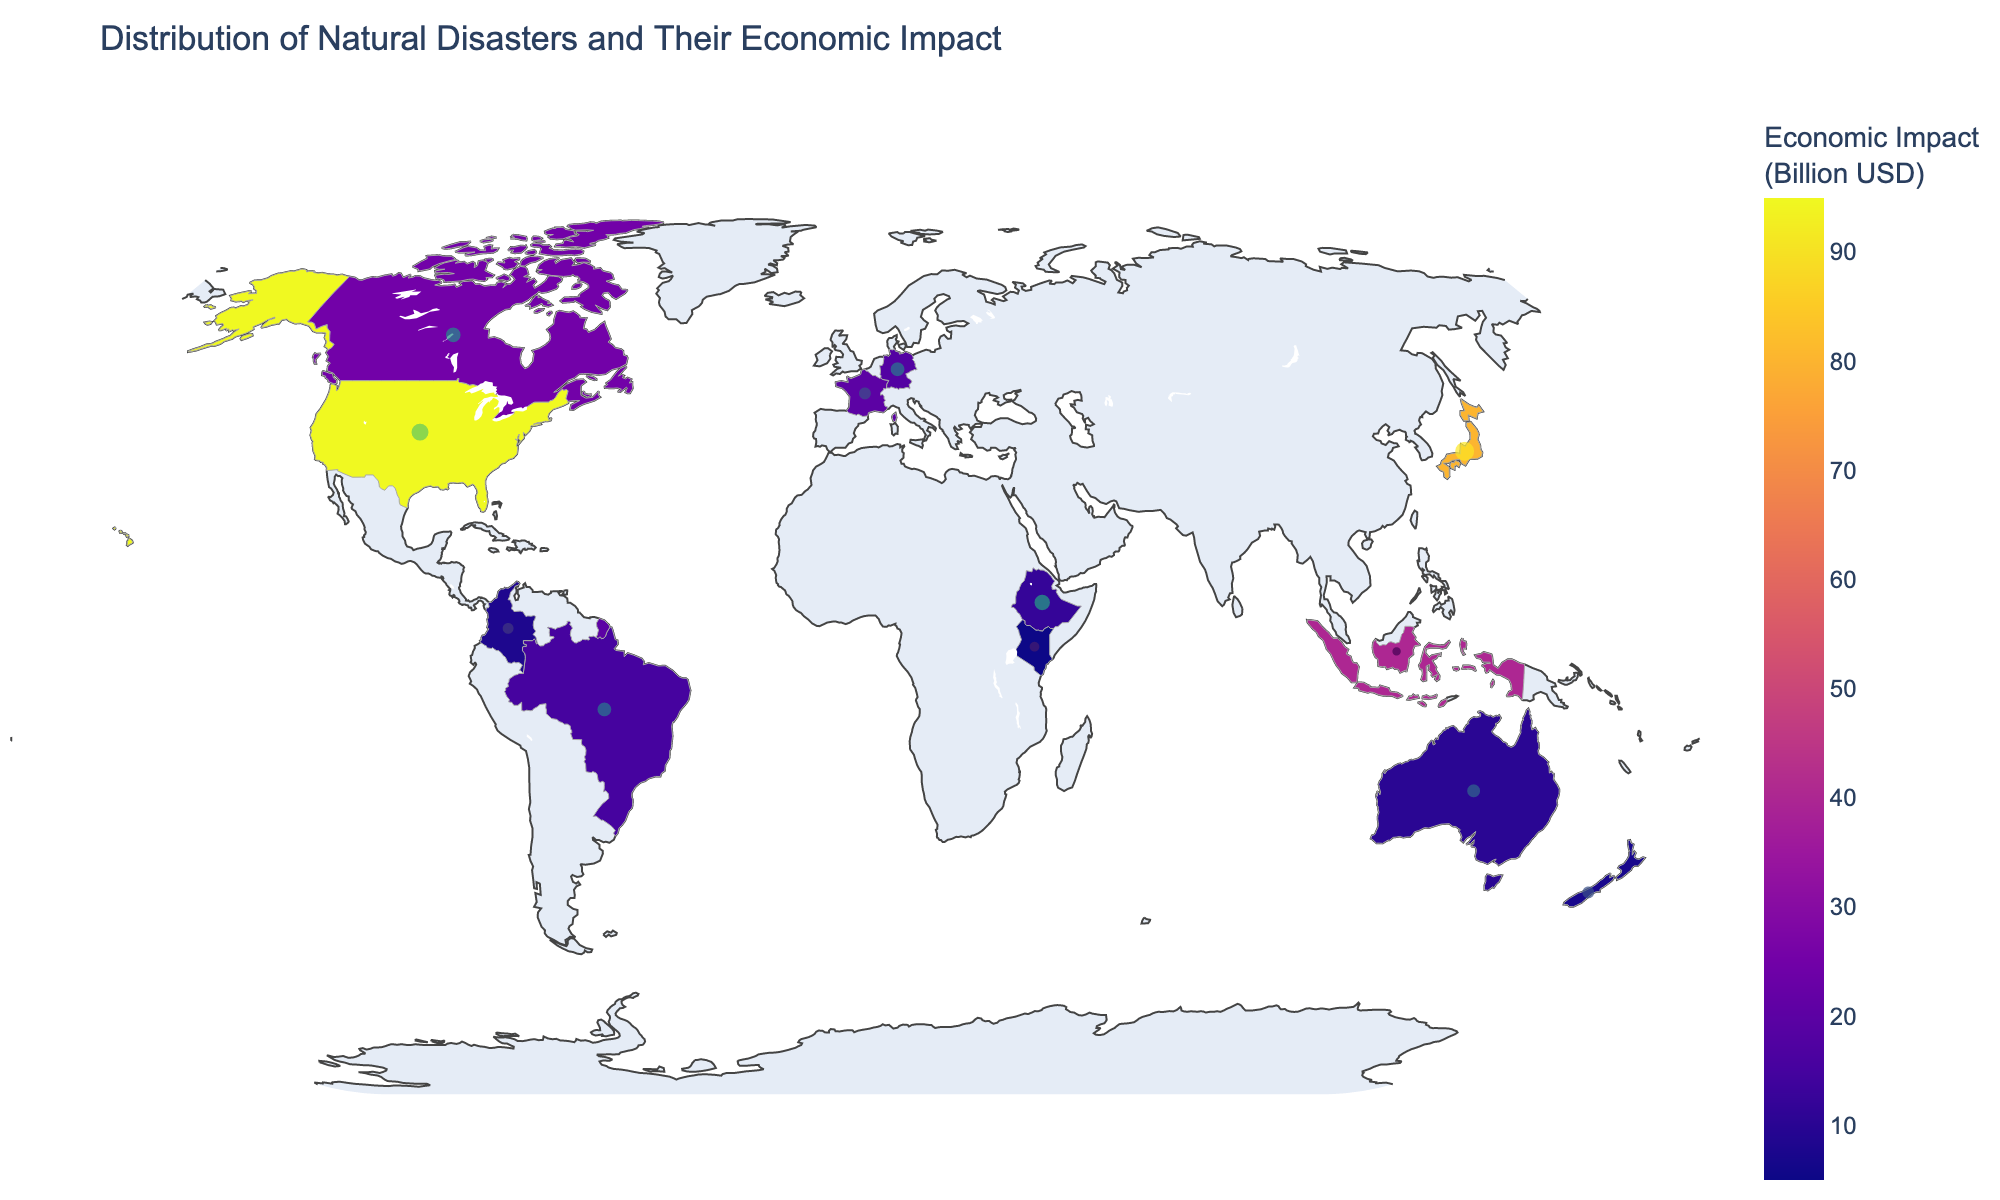Which continent has the highest economic impact from natural disasters? By referring to the color scale and the highest z-values, which indicate economic impact, we can see that North America stands out with the highest economic impact, primarily due to Hurricanes in the United States.
Answer: North America Which disaster type in Asia causes the most economic impact? Observing the countries in Asia, Japan experienced earthquakes with significant economic impacts by noting the color and z-value assigned to Japan.
Answer: Earthquake Comparing Europe and South America, which continent faces more frequent natural disasters? By looking at the scatter plot markers (size representing frequency), it is evident that Europe, with multiple disaster types like heatwave and severe storms, faces more frequent natural disasters compared to South America, which has floods and landslides.
Answer: Europe What is the most common type of natural disaster in Oceania? The figure shows Oceania with two disaster types: Cyclones and Floods. Cyclones appear more frequently (7 times) compared to Floods (6 times).
Answer: Cyclone How does the economic impact of droughts in Africa compare to hurricanes in North America? By comparing the economic impact, with Africa's droughts leading to an economic impact of 12 billion USD and the hurricanes in North America causing 95 billion USD, it is clear that North America's hurricanes have a much higher economic impact.
Answer: Hurricanes in North America have a higher impact What is the total frequency of wildfires in North America and cyclones in Oceania? The frequency of wildfires in North America is 9, and cyclones in Oceania is 7. Summing these up, the total frequency is 9 + 7 = 16.
Answer: 16 Which country in Europe is most affected by heatwaves? The heatwave disaster type in Europe highlights France as the most affected country.
Answer: France How does the economic impact of tsunamis in Asia compare to the global average impact of the disasters shown? The economic impact of tsunamis in Asia (40 billion USD) needs to be compared against the average impact of all disasters. Summing all given impacts (x) and dividing by the number of disaster types (12) results in an average economic impact far greater than the global average, thus demonstrating a significant deviation.
Answer: Higher than global average How many disaster types in total are represented in the figure? Counting each unique disaster type across all continents listed: Hurricane, Flood, Heatwave, Drought, Earthquake, Cyclone, Wildfire, Landslide, Severe Storm, Locust Swarm, Tsunami. There are 11 different disaster types.
Answer: 11 Which two countries have nearly similar economic impacts from disasters, and what are they? By comparing the economic impacts, Germany (18 billion USD from Severe Storms) and France (20 billion USD from Heatwaves) have nearly similar impacts.
Answer: Germany and France, close to 18-20 billion USD 